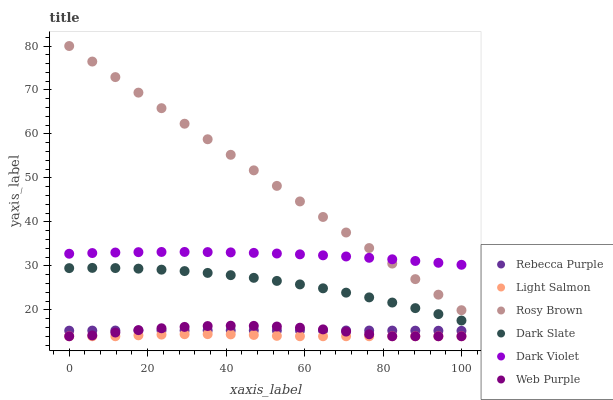Does Light Salmon have the minimum area under the curve?
Answer yes or no. Yes. Does Rosy Brown have the maximum area under the curve?
Answer yes or no. Yes. Does Dark Violet have the minimum area under the curve?
Answer yes or no. No. Does Dark Violet have the maximum area under the curve?
Answer yes or no. No. Is Rosy Brown the smoothest?
Answer yes or no. Yes. Is Web Purple the roughest?
Answer yes or no. Yes. Is Dark Violet the smoothest?
Answer yes or no. No. Is Dark Violet the roughest?
Answer yes or no. No. Does Light Salmon have the lowest value?
Answer yes or no. Yes. Does Rosy Brown have the lowest value?
Answer yes or no. No. Does Rosy Brown have the highest value?
Answer yes or no. Yes. Does Dark Violet have the highest value?
Answer yes or no. No. Is Web Purple less than Dark Violet?
Answer yes or no. Yes. Is Dark Slate greater than Rebecca Purple?
Answer yes or no. Yes. Does Rebecca Purple intersect Web Purple?
Answer yes or no. Yes. Is Rebecca Purple less than Web Purple?
Answer yes or no. No. Is Rebecca Purple greater than Web Purple?
Answer yes or no. No. Does Web Purple intersect Dark Violet?
Answer yes or no. No. 